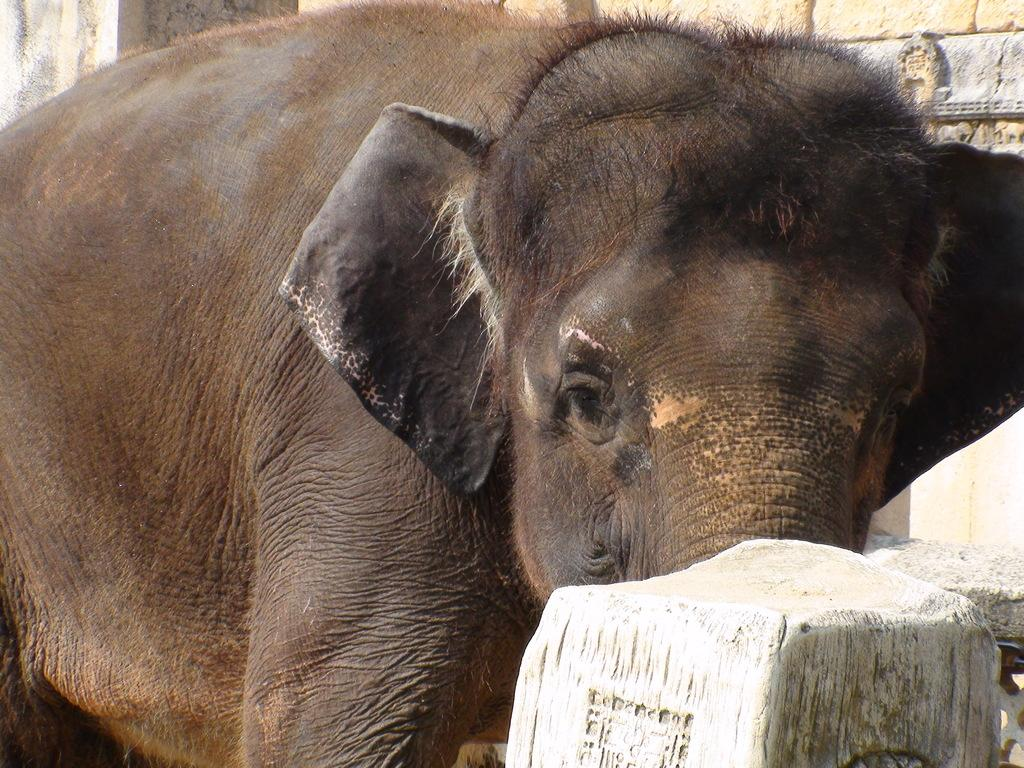What is the main subject of the image? There is an elephant in the center of the image. Can you describe the background of the image? There is a wall in the background of the image. What type of sign is the elephant holding in the image? There is no sign present in the image; the elephant is not holding anything. 